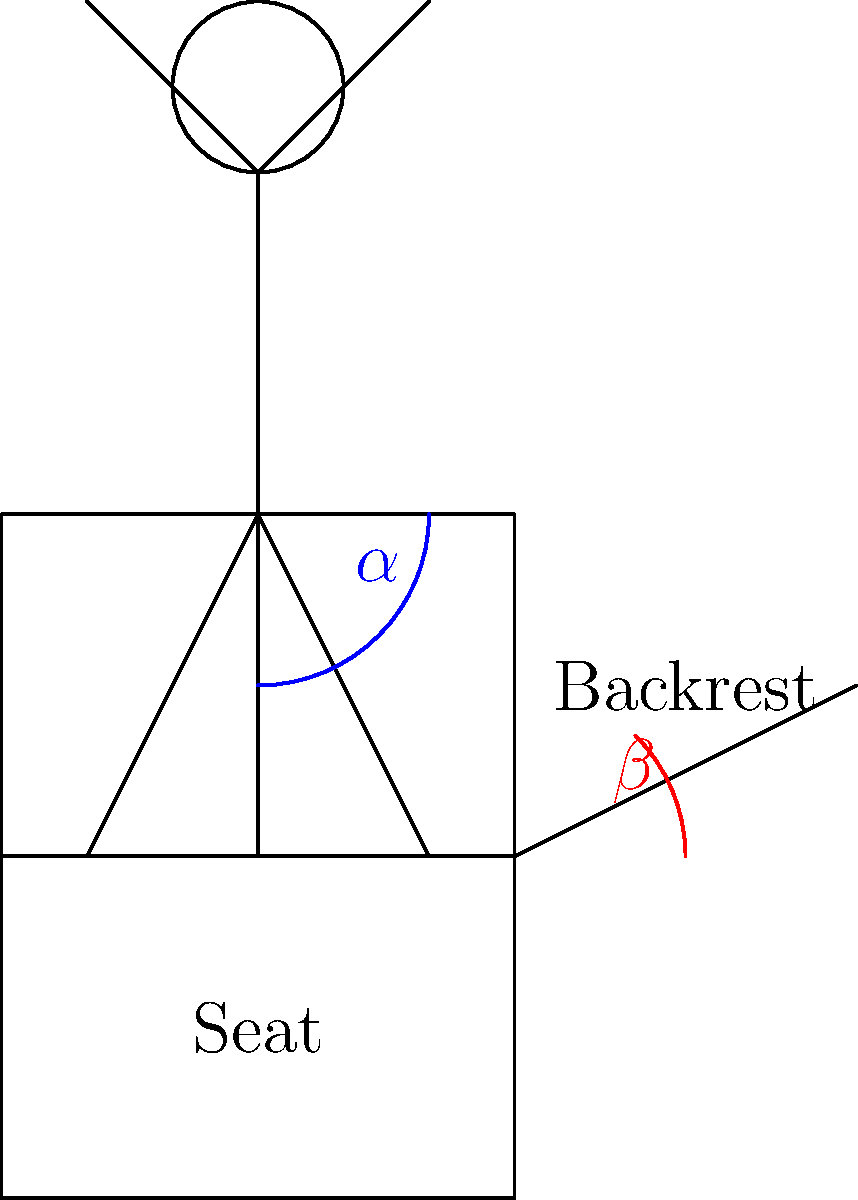In the diagram above, which represents an ergonomic seating position for an individual with sensory sensitivities, what is the ideal range for the angle $\alpha$ between the upper and lower leg, and the angle $\beta$ between the seat and backrest to provide optimal comfort and support? To determine the ideal ergonomic seating position for individuals with sensory sensitivities, we need to consider several factors:

1. Angle $\alpha$ (between upper and lower leg):
   - This angle is crucial for reducing pressure on the lower back and promoting good circulation.
   - A 90-degree angle can cause discomfort and restrict blood flow.
   - The ideal range is between 95-135 degrees, with 110-120 degrees being optimal for most people.

2. Angle $\beta$ (between seat and backrest):
   - This angle affects spinal alignment and overall posture.
   - A 90-degree angle can cause excessive strain on the lower back.
   - The ideal range is between 100-110 degrees, allowing for a slight recline while maintaining proper support.

3. Additional considerations for sensory sensitivities:
   - The chair should have adjustable features to accommodate individual preferences.
   - Soft, breathable materials can help reduce tactile sensitivities.
   - A chair with minimal vibration or movement is preferable to reduce vestibular sensitivities.

4. Other ergonomic factors:
   - Feet should be flat on the floor or a footrest.
   - The seat depth should allow for a small gap (2-4 inches) between the edge of the seat and the back of the knees.
   - Armrests should be adjustable to support the arms at a 90-degree angle.

Taking all these factors into account, the ideal ergonomic seating position for individuals with sensory sensitivities would have:
- Angle $\alpha$ between 110-120 degrees
- Angle $\beta$ between 100-110 degrees

These angles provide optimal comfort, support, and accommodation for sensory needs while promoting good posture and reducing physical strain.
Answer: $\alpha$: 110-120°, $\beta$: 100-110° 